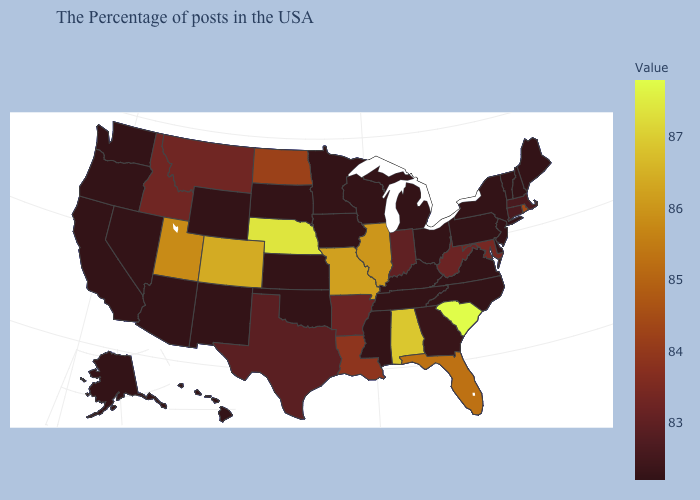Which states hav the highest value in the South?
Concise answer only. South Carolina. Does Illinois have a lower value than Oklahoma?
Be succinct. No. Which states have the highest value in the USA?
Be succinct. South Carolina. Among the states that border Illinois , which have the lowest value?
Short answer required. Kentucky, Wisconsin, Iowa. Which states have the highest value in the USA?
Quick response, please. South Carolina. Among the states that border North Carolina , does Georgia have the lowest value?
Write a very short answer. No. Does the map have missing data?
Concise answer only. No. Among the states that border Florida , which have the highest value?
Quick response, please. Alabama. 